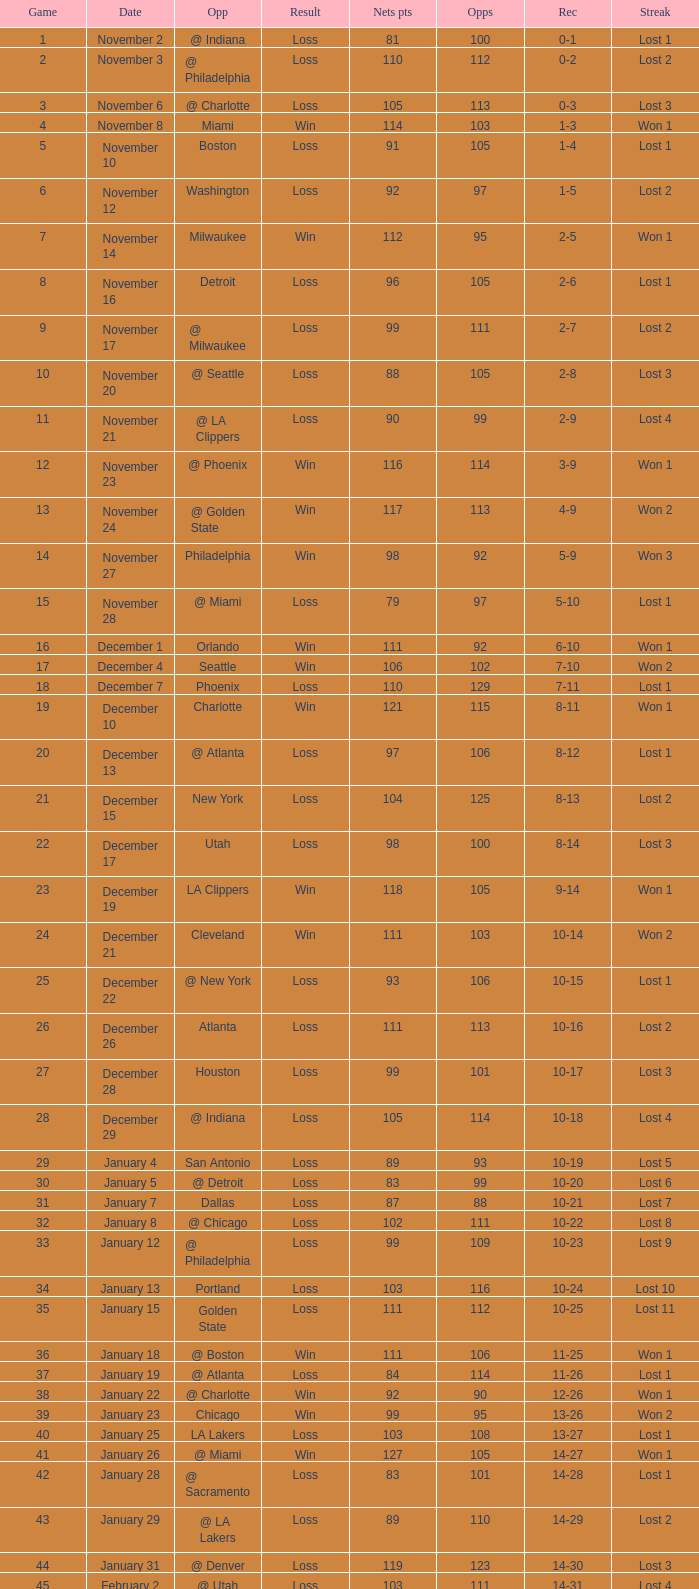What was the average point total for the nets in games before game 9 where the opponents scored less than 95? None. Give me the full table as a dictionary. {'header': ['Game', 'Date', 'Opp', 'Result', 'Nets pts', 'Opps', 'Rec', 'Streak'], 'rows': [['1', 'November 2', '@ Indiana', 'Loss', '81', '100', '0-1', 'Lost 1'], ['2', 'November 3', '@ Philadelphia', 'Loss', '110', '112', '0-2', 'Lost 2'], ['3', 'November 6', '@ Charlotte', 'Loss', '105', '113', '0-3', 'Lost 3'], ['4', 'November 8', 'Miami', 'Win', '114', '103', '1-3', 'Won 1'], ['5', 'November 10', 'Boston', 'Loss', '91', '105', '1-4', 'Lost 1'], ['6', 'November 12', 'Washington', 'Loss', '92', '97', '1-5', 'Lost 2'], ['7', 'November 14', 'Milwaukee', 'Win', '112', '95', '2-5', 'Won 1'], ['8', 'November 16', 'Detroit', 'Loss', '96', '105', '2-6', 'Lost 1'], ['9', 'November 17', '@ Milwaukee', 'Loss', '99', '111', '2-7', 'Lost 2'], ['10', 'November 20', '@ Seattle', 'Loss', '88', '105', '2-8', 'Lost 3'], ['11', 'November 21', '@ LA Clippers', 'Loss', '90', '99', '2-9', 'Lost 4'], ['12', 'November 23', '@ Phoenix', 'Win', '116', '114', '3-9', 'Won 1'], ['13', 'November 24', '@ Golden State', 'Win', '117', '113', '4-9', 'Won 2'], ['14', 'November 27', 'Philadelphia', 'Win', '98', '92', '5-9', 'Won 3'], ['15', 'November 28', '@ Miami', 'Loss', '79', '97', '5-10', 'Lost 1'], ['16', 'December 1', 'Orlando', 'Win', '111', '92', '6-10', 'Won 1'], ['17', 'December 4', 'Seattle', 'Win', '106', '102', '7-10', 'Won 2'], ['18', 'December 7', 'Phoenix', 'Loss', '110', '129', '7-11', 'Lost 1'], ['19', 'December 10', 'Charlotte', 'Win', '121', '115', '8-11', 'Won 1'], ['20', 'December 13', '@ Atlanta', 'Loss', '97', '106', '8-12', 'Lost 1'], ['21', 'December 15', 'New York', 'Loss', '104', '125', '8-13', 'Lost 2'], ['22', 'December 17', 'Utah', 'Loss', '98', '100', '8-14', 'Lost 3'], ['23', 'December 19', 'LA Clippers', 'Win', '118', '105', '9-14', 'Won 1'], ['24', 'December 21', 'Cleveland', 'Win', '111', '103', '10-14', 'Won 2'], ['25', 'December 22', '@ New York', 'Loss', '93', '106', '10-15', 'Lost 1'], ['26', 'December 26', 'Atlanta', 'Loss', '111', '113', '10-16', 'Lost 2'], ['27', 'December 28', 'Houston', 'Loss', '99', '101', '10-17', 'Lost 3'], ['28', 'December 29', '@ Indiana', 'Loss', '105', '114', '10-18', 'Lost 4'], ['29', 'January 4', 'San Antonio', 'Loss', '89', '93', '10-19', 'Lost 5'], ['30', 'January 5', '@ Detroit', 'Loss', '83', '99', '10-20', 'Lost 6'], ['31', 'January 7', 'Dallas', 'Loss', '87', '88', '10-21', 'Lost 7'], ['32', 'January 8', '@ Chicago', 'Loss', '102', '111', '10-22', 'Lost 8'], ['33', 'January 12', '@ Philadelphia', 'Loss', '99', '109', '10-23', 'Lost 9'], ['34', 'January 13', 'Portland', 'Loss', '103', '116', '10-24', 'Lost 10'], ['35', 'January 15', 'Golden State', 'Loss', '111', '112', '10-25', 'Lost 11'], ['36', 'January 18', '@ Boston', 'Win', '111', '106', '11-25', 'Won 1'], ['37', 'January 19', '@ Atlanta', 'Loss', '84', '114', '11-26', 'Lost 1'], ['38', 'January 22', '@ Charlotte', 'Win', '92', '90', '12-26', 'Won 1'], ['39', 'January 23', 'Chicago', 'Win', '99', '95', '13-26', 'Won 2'], ['40', 'January 25', 'LA Lakers', 'Loss', '103', '108', '13-27', 'Lost 1'], ['41', 'January 26', '@ Miami', 'Win', '127', '105', '14-27', 'Won 1'], ['42', 'January 28', '@ Sacramento', 'Loss', '83', '101', '14-28', 'Lost 1'], ['43', 'January 29', '@ LA Lakers', 'Loss', '89', '110', '14-29', 'Lost 2'], ['44', 'January 31', '@ Denver', 'Loss', '119', '123', '14-30', 'Lost 3'], ['45', 'February 2', '@ Utah', 'Loss', '103', '111', '14-31', 'Lost 4'], ['46', 'February 4', '@ Portland', 'Loss', '102', '117', '14-32', 'Lost 5'], ['47', 'February 6', 'Miami', 'Loss', '119', '134', '14-33', 'Lost 6'], ['48', 'February 7', '@ Washington', 'Loss', '117', '124', '14-34', 'Lost 7'], ['49', 'February 13', 'Atlanta', 'Win', '140', '106', '15-34', 'Won 1'], ['50', 'February 15', 'Denver', 'Win', '138', '110', '16-34', 'Won 2'], ['51', 'February 16', '@ Chicago', 'Loss', '87', '99', '16-35', 'Lost 1'], ['52', 'February 19', 'Sacramento', 'Win', '97', '83', '17-35', 'Won 1'], ['53', 'February 22', '@ Boston', 'Loss', '99', '111', '17-36', 'Lost 1'], ['54', 'February 23', 'Philadelphia', 'Loss', '90', '103', '17-37', 'Lost 2'], ['55', 'February 26', 'Indiana', 'Win', '129', '104', '18-37', 'Won 1'], ['56', 'February 28', 'Milwaukee', 'Win', '98', '93', '19-37', 'Won 2'], ['57', 'March 2', 'New York', 'Loss', '105', '115', '19-38', 'Lost 1'], ['58', 'March 4', '@ Dallas', 'Loss', '100', '102', '19-39', 'Lost 2'], ['59', 'March 5', '@ Houston', 'Loss', '100', '112', '19-40', 'Lost 3'], ['60', 'March 7', '@ San Antonio', 'Loss', '99', '111', '19-41', 'Lost 4'], ['61', 'March 10', '@ Miami', 'Loss', '88', '101', '19-42', 'Lost 5'], ['62', 'March 11', '@ New York', 'Loss', '85', '90', '19-43', 'Lost 6'], ['63', 'March 14', 'Detroit', 'Win', '118', '110', '20-43', 'Won 1'], ['64', 'March 16', 'Washington', 'Win', '110', '86', '21-43', 'Won 2'], ['65', 'March 17', 'Charlotte', 'Loss', '108', '121', '21-44', 'Lost 1'], ['66', 'March 20', 'Minnesota', 'Win', '118', '111', '22-44', 'Won 1'], ['67', 'March 22', '@ Detroit', 'Loss', '93', '109', '22-45', 'Lost 1'], ['68', 'March 23', '@ Cleveland', 'Loss', '82', '108', '22-46', 'Lost 2'], ['69', 'March 25', '@ Washington', 'Loss', '106', '113', '22-47', 'Lost 3'], ['70', 'March 26', 'Philadelphia', 'Win', '98', '95', '23-47', 'Won 1'], ['71', 'March 28', 'Chicago', 'Loss', '94', '128', '23-48', 'Lost 1'], ['72', 'March 30', 'New York', 'Loss', '117', '130', '23-49', 'Lost 2'], ['73', 'April 2', 'Boston', 'Loss', '77', '94', '23-50', 'Lost 3'], ['74', 'April 4', '@ Boston', 'Loss', '104', '123', '23-51', 'Lost 4'], ['75', 'April 6', '@ Milwaukee', 'Loss', '114', '133', '23-52', 'Lost 5'], ['76', 'April 9', '@ Minnesota', 'Loss', '89', '109', '23-53', 'Lost 6'], ['77', 'April 12', 'Cleveland', 'Win', '104', '103', '24-53', 'Won 1'], ['78', 'April 13', '@ Cleveland', 'Loss', '98', '102', '24-54', 'Lost 1'], ['79', 'April 16', 'Indiana', 'Loss', '126', '132', '24-55', 'Lost 2'], ['80', 'April 18', '@ Washington', 'Win', '108', '103', '25-55', 'Won 1'], ['81', 'April 20', 'Miami', 'Win', '118', '103', '26-55', 'Won 2'], ['82', 'April 21', '@ Orlando', 'Loss', '110', '120', '26-56', 'Lost 1']]} 